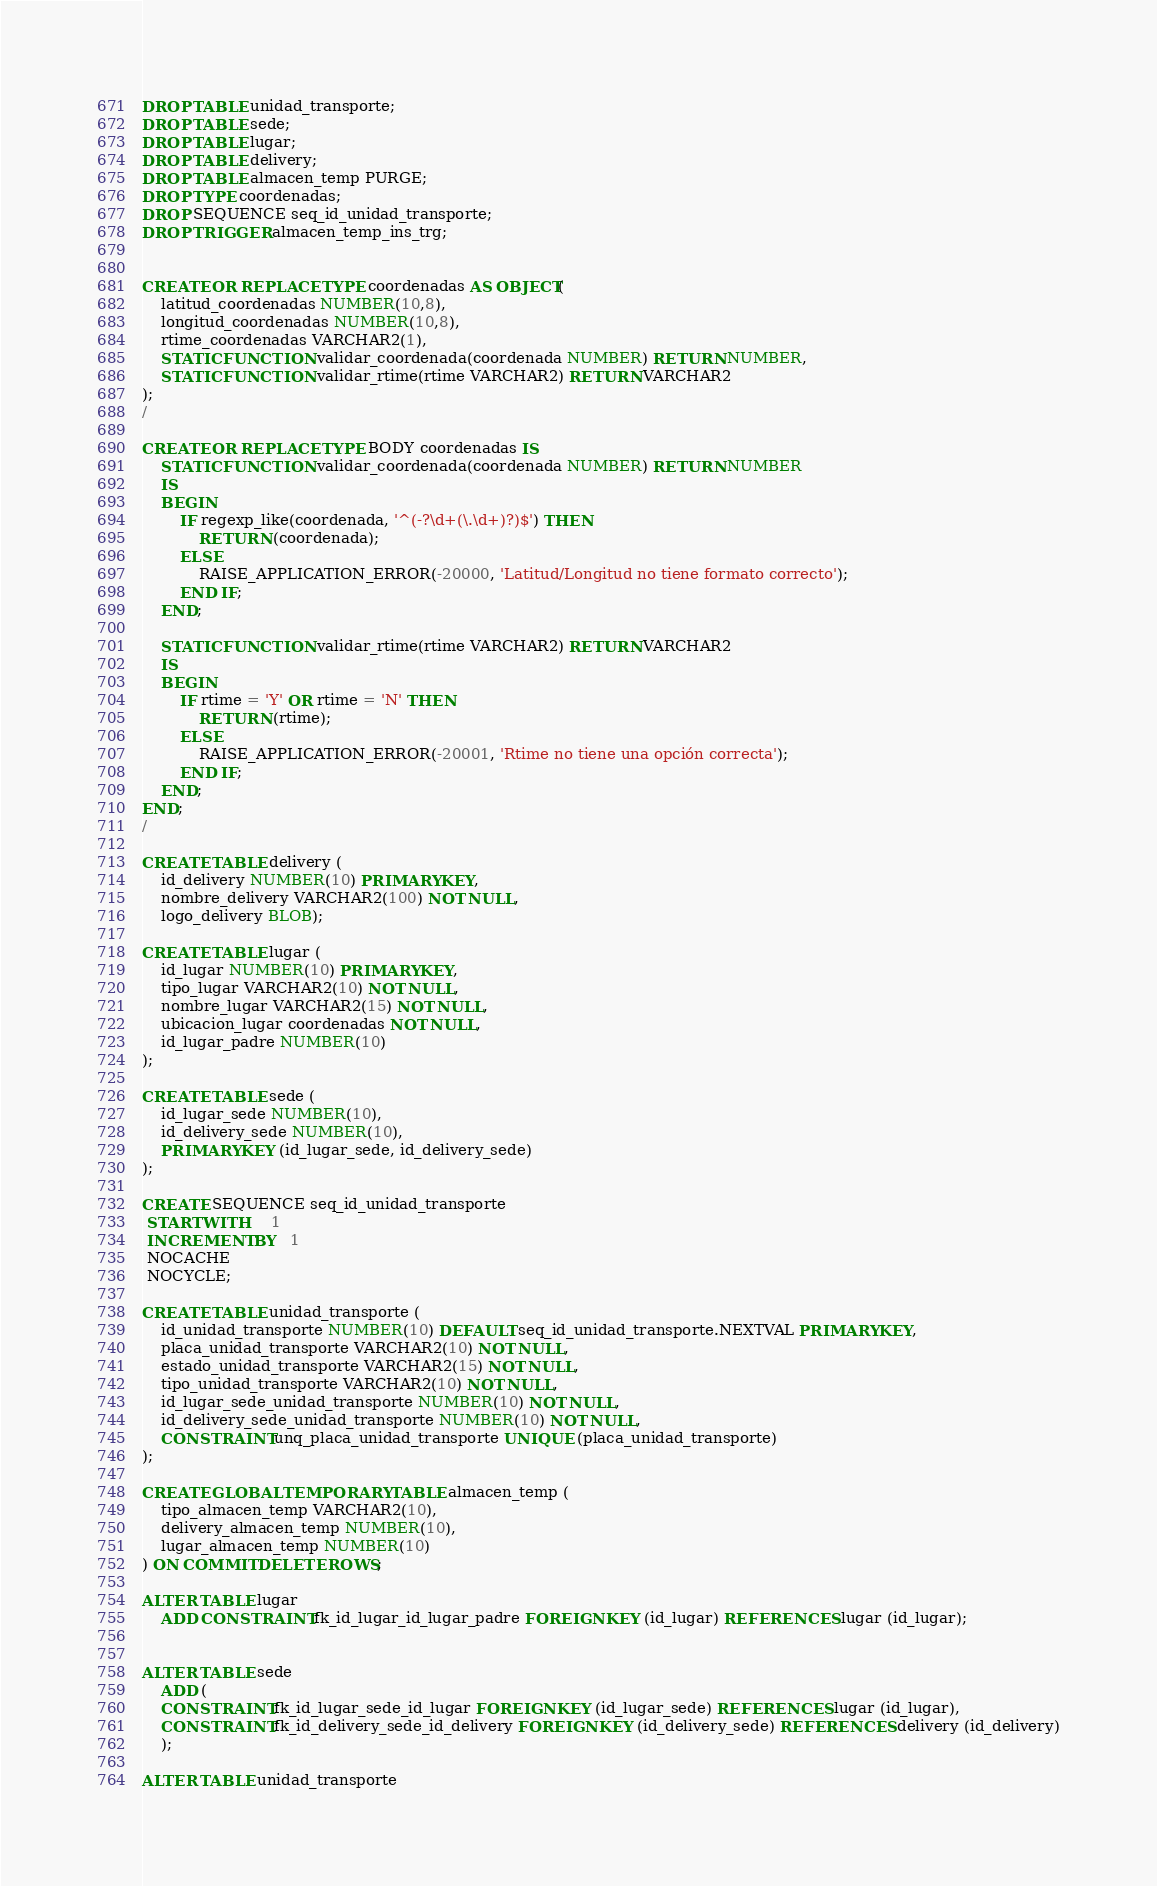<code> <loc_0><loc_0><loc_500><loc_500><_SQL_>DROP TABLE unidad_transporte;
DROP TABLE sede;
DROP TABLE lugar;
DROP TABLE delivery;
DROP TABLE almacen_temp PURGE;
DROP TYPE coordenadas;
DROP SEQUENCE seq_id_unidad_transporte;
DROP TRIGGER almacen_temp_ins_trg;


CREATE OR REPLACE TYPE coordenadas AS OBJECT(
    latitud_coordenadas NUMBER(10,8),
    longitud_coordenadas NUMBER(10,8),
    rtime_coordenadas VARCHAR2(1),
    STATIC FUNCTION validar_coordenada(coordenada NUMBER) RETURN NUMBER,
    STATIC FUNCTION validar_rtime(rtime VARCHAR2) RETURN VARCHAR2
);
/

CREATE OR REPLACE TYPE BODY coordenadas IS
    STATIC FUNCTION validar_coordenada(coordenada NUMBER) RETURN NUMBER
    IS
    BEGIN
        IF regexp_like(coordenada, '^(-?\d+(\.\d+)?)$') THEN
            RETURN (coordenada);
        ELSE
            RAISE_APPLICATION_ERROR(-20000, 'Latitud/Longitud no tiene formato correcto');
        END IF;
    END;

    STATIC FUNCTION validar_rtime(rtime VARCHAR2) RETURN VARCHAR2
    IS
    BEGIN
        IF rtime = 'Y' OR rtime = 'N' THEN
            RETURN (rtime);
        ELSE
            RAISE_APPLICATION_ERROR(-20001, 'Rtime no tiene una opción correcta');
        END IF;
    END;
END;
/

CREATE TABLE delivery (
    id_delivery NUMBER(10) PRIMARY KEY,
    nombre_delivery VARCHAR2(100) NOT NULL,
    logo_delivery BLOB);

CREATE TABLE lugar (
    id_lugar NUMBER(10) PRIMARY KEY,
    tipo_lugar VARCHAR2(10) NOT NULL,
    nombre_lugar VARCHAR2(15) NOT NULL,
    ubicacion_lugar coordenadas NOT NULL,
    id_lugar_padre NUMBER(10)
);

CREATE TABLE sede (
    id_lugar_sede NUMBER(10),
    id_delivery_sede NUMBER(10),
    PRIMARY KEY (id_lugar_sede, id_delivery_sede)
);

CREATE SEQUENCE seq_id_unidad_transporte
 START WITH     1
 INCREMENT BY   1
 NOCACHE
 NOCYCLE;

CREATE TABLE unidad_transporte (
    id_unidad_transporte NUMBER(10) DEFAULT seq_id_unidad_transporte.NEXTVAL PRIMARY KEY,
    placa_unidad_transporte VARCHAR2(10) NOT NULL,
    estado_unidad_transporte VARCHAR2(15) NOT NULL,
    tipo_unidad_transporte VARCHAR2(10) NOT NULL,
    id_lugar_sede_unidad_transporte NUMBER(10) NOT NULL,
    id_delivery_sede_unidad_transporte NUMBER(10) NOT NULL,
    CONSTRAINT unq_placa_unidad_transporte UNIQUE (placa_unidad_transporte)
);

CREATE GLOBAL TEMPORARY TABLE almacen_temp (
    tipo_almacen_temp VARCHAR2(10),
    delivery_almacen_temp NUMBER(10),
    lugar_almacen_temp NUMBER(10)
) ON COMMIT DELETE ROWS;

ALTER TABLE lugar
    ADD CONSTRAINT fk_id_lugar_id_lugar_padre FOREIGN KEY (id_lugar) REFERENCES lugar (id_lugar);


ALTER TABLE sede
    ADD (
    CONSTRAINT fk_id_lugar_sede_id_lugar FOREIGN KEY (id_lugar_sede) REFERENCES lugar (id_lugar),
    CONSTRAINT fk_id_delivery_sede_id_delivery FOREIGN KEY (id_delivery_sede) REFERENCES delivery (id_delivery)
    );

ALTER TABLE unidad_transporte</code> 